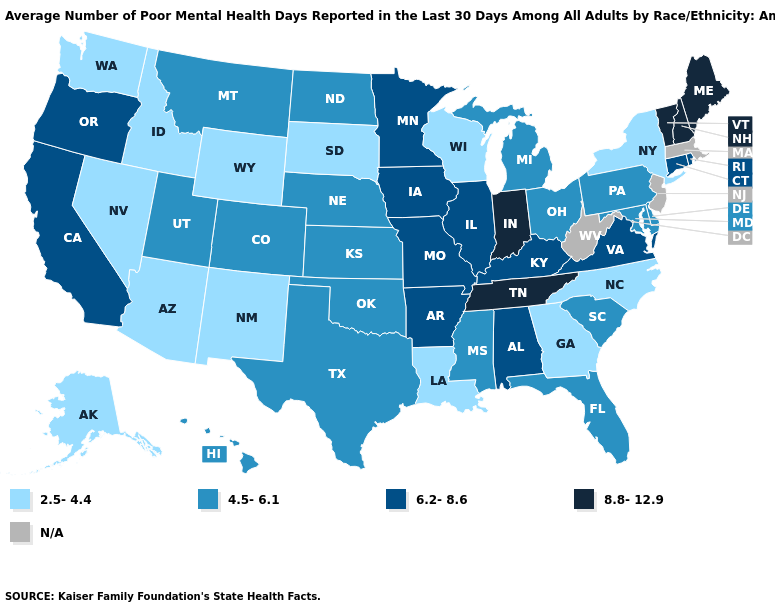Name the states that have a value in the range 6.2-8.6?
Answer briefly. Alabama, Arkansas, California, Connecticut, Illinois, Iowa, Kentucky, Minnesota, Missouri, Oregon, Rhode Island, Virginia. Name the states that have a value in the range N/A?
Concise answer only. Massachusetts, New Jersey, West Virginia. Name the states that have a value in the range 4.5-6.1?
Quick response, please. Colorado, Delaware, Florida, Hawaii, Kansas, Maryland, Michigan, Mississippi, Montana, Nebraska, North Dakota, Ohio, Oklahoma, Pennsylvania, South Carolina, Texas, Utah. What is the highest value in states that border North Dakota?
Short answer required. 6.2-8.6. What is the value of Montana?
Write a very short answer. 4.5-6.1. What is the value of Illinois?
Answer briefly. 6.2-8.6. Does Hawaii have the highest value in the USA?
Keep it brief. No. Does the first symbol in the legend represent the smallest category?
Give a very brief answer. Yes. Name the states that have a value in the range 8.8-12.9?
Quick response, please. Indiana, Maine, New Hampshire, Tennessee, Vermont. What is the value of South Dakota?
Be succinct. 2.5-4.4. Name the states that have a value in the range 2.5-4.4?
Short answer required. Alaska, Arizona, Georgia, Idaho, Louisiana, Nevada, New Mexico, New York, North Carolina, South Dakota, Washington, Wisconsin, Wyoming. What is the highest value in states that border Wyoming?
Short answer required. 4.5-6.1. Does Tennessee have the highest value in the South?
Quick response, please. Yes. What is the lowest value in states that border Colorado?
Write a very short answer. 2.5-4.4. 